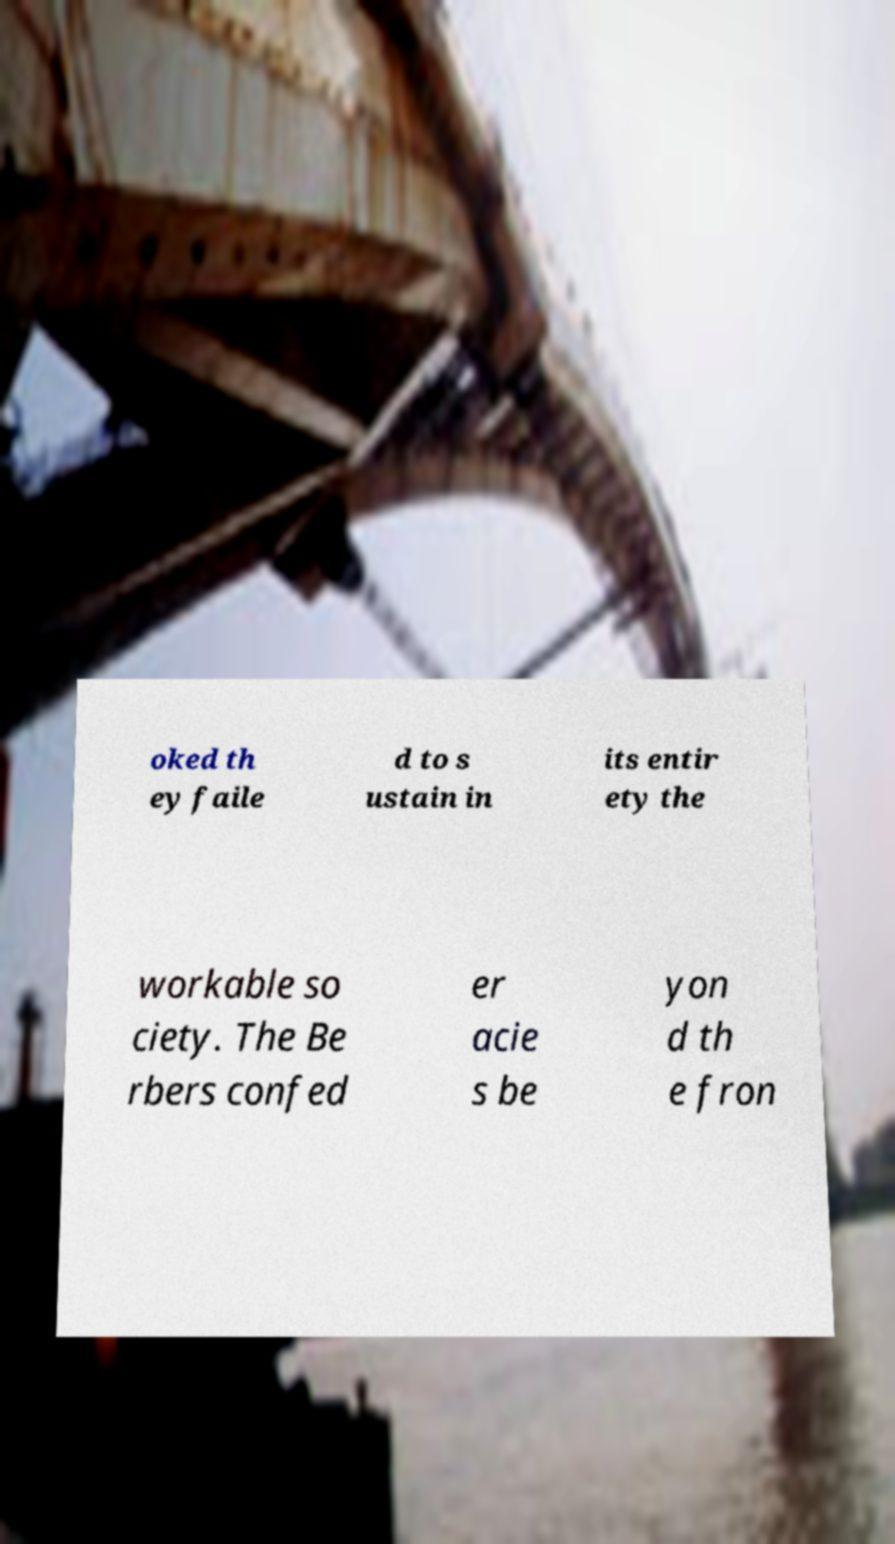For documentation purposes, I need the text within this image transcribed. Could you provide that? oked th ey faile d to s ustain in its entir ety the workable so ciety. The Be rbers confed er acie s be yon d th e fron 